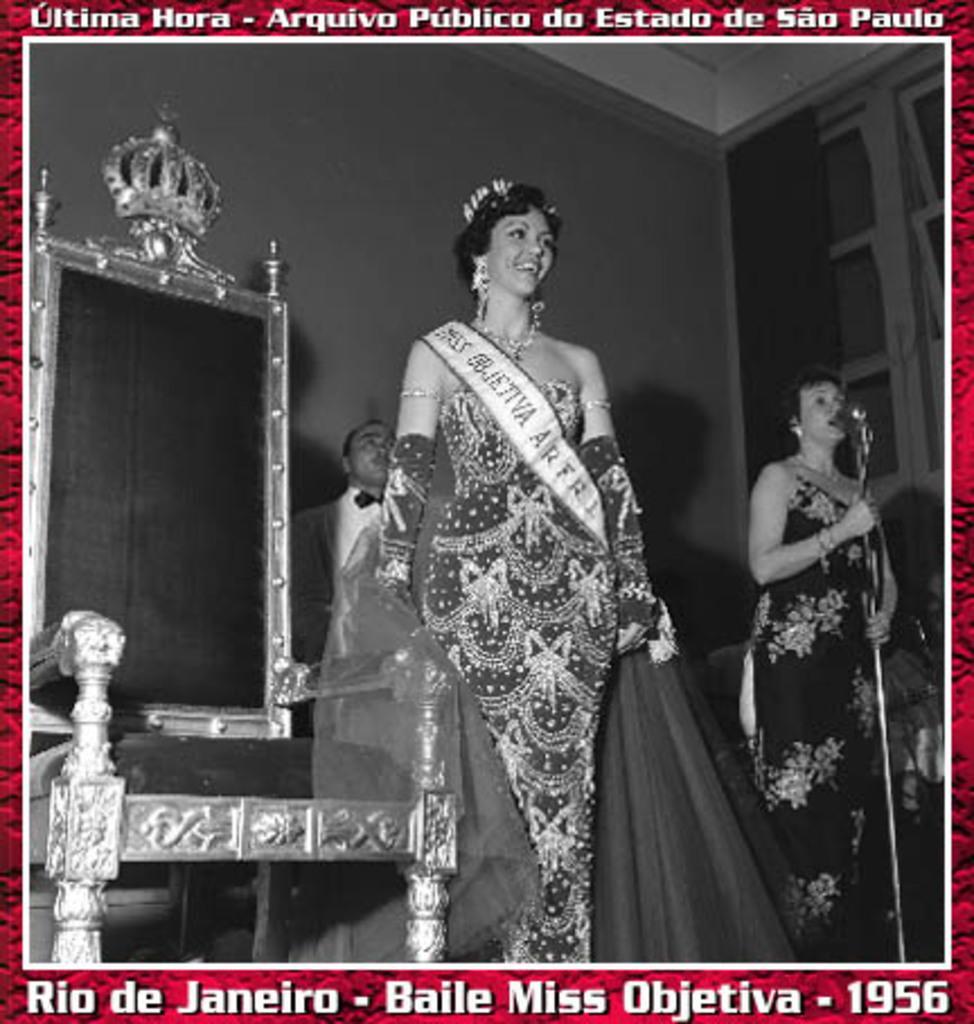Please provide a concise description of this image. It is a black and white image. In this image we can see the woman standing and smiling in the center. We can also see the woman on the right in front of the mike stand. We can also see the chair and also the person in the background. Image also consists of the window with the curtain also the wall and the image has red color borders. We can also see the text at the top and at the bottom. 